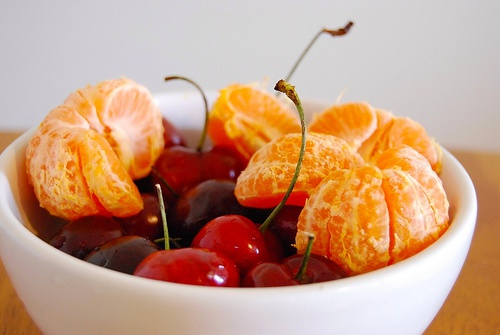Describe the objects in this image and their specific colors. I can see bowl in lightgray, orange, and maroon tones, orange in lightgray, orange, red, and tan tones, orange in lightgray, orange, red, and tan tones, and orange in lightgray, orange, and red tones in this image. 